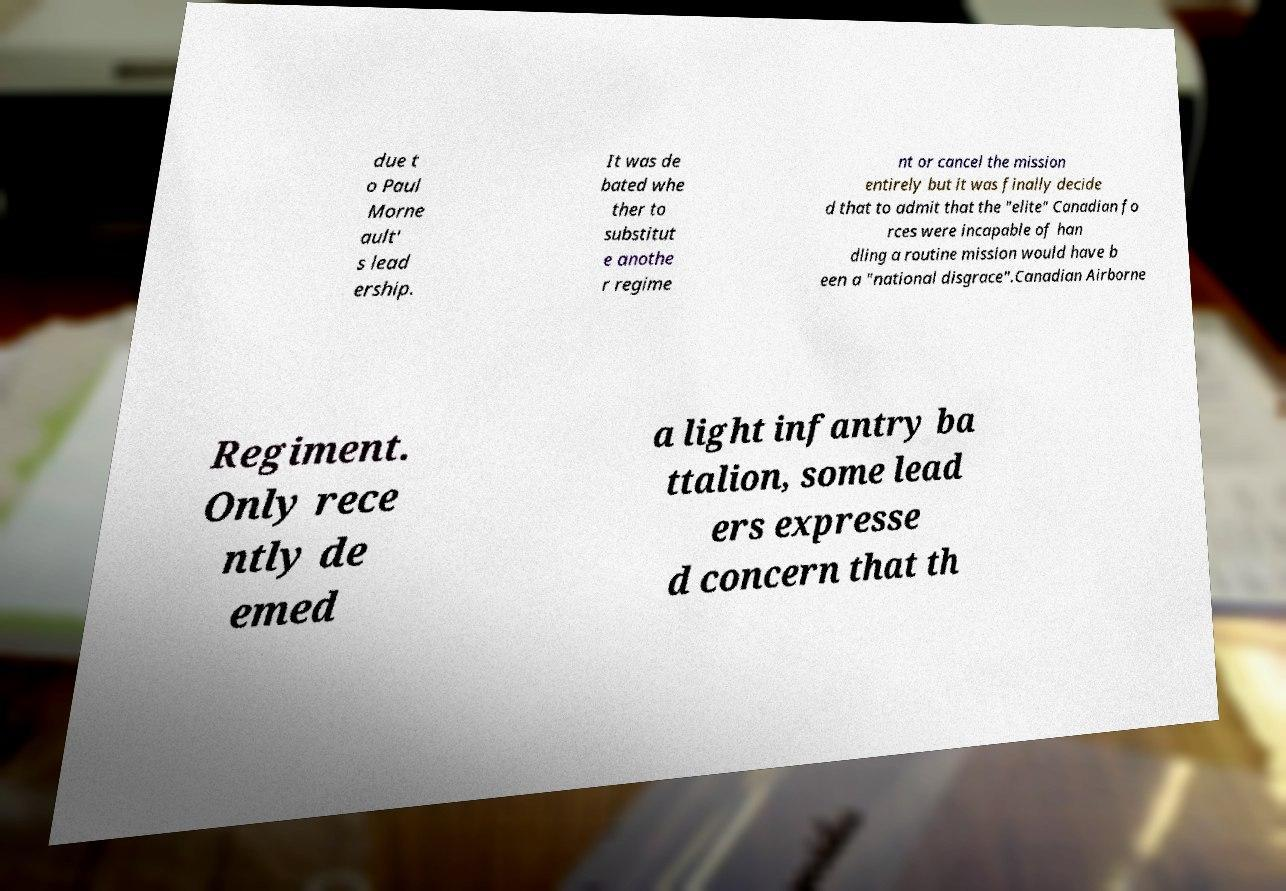I need the written content from this picture converted into text. Can you do that? due t o Paul Morne ault' s lead ership. It was de bated whe ther to substitut e anothe r regime nt or cancel the mission entirely but it was finally decide d that to admit that the "elite" Canadian fo rces were incapable of han dling a routine mission would have b een a "national disgrace".Canadian Airborne Regiment. Only rece ntly de emed a light infantry ba ttalion, some lead ers expresse d concern that th 